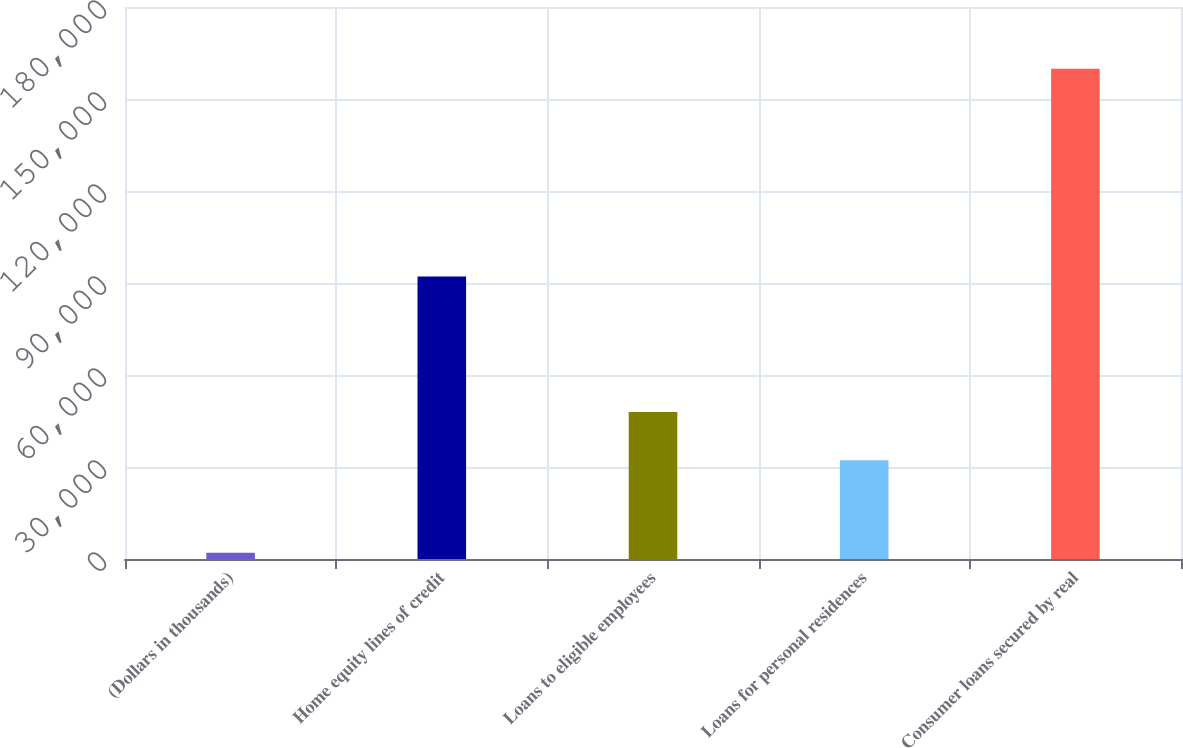<chart> <loc_0><loc_0><loc_500><loc_500><bar_chart><fcel>(Dollars in thousands)<fcel>Home equity lines of credit<fcel>Loans to eligible employees<fcel>Loans for personal residences<fcel>Consumer loans secured by real<nl><fcel>2006<fcel>92093<fcel>47955.5<fcel>32173<fcel>159831<nl></chart> 